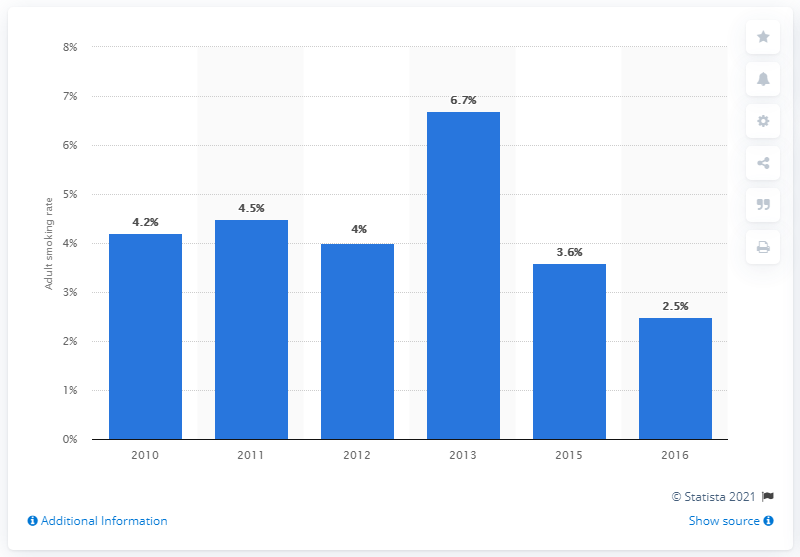Mention a couple of crucial points in this snapshot. In 2016, it was reported that approximately 2.5% of females in Indonesia were smokers. In 2010, the female smoking rate in Indonesia was 4.2%. 